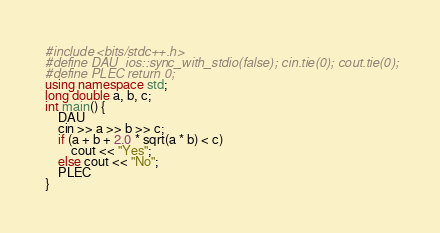Convert code to text. <code><loc_0><loc_0><loc_500><loc_500><_C++_>#include <bits/stdc++.h>
#define DAU  ios::sync_with_stdio(false); cin.tie(0); cout.tie(0);
#define PLEC return 0;
using namespace std;
long double a, b, c;
int main() {
    DAU
    cin >> a >> b >> c;
    if (a + b + 2.0 * sqrt(a * b) < c)
        cout << "Yes";
    else cout << "No";
    PLEC
}
</code> 